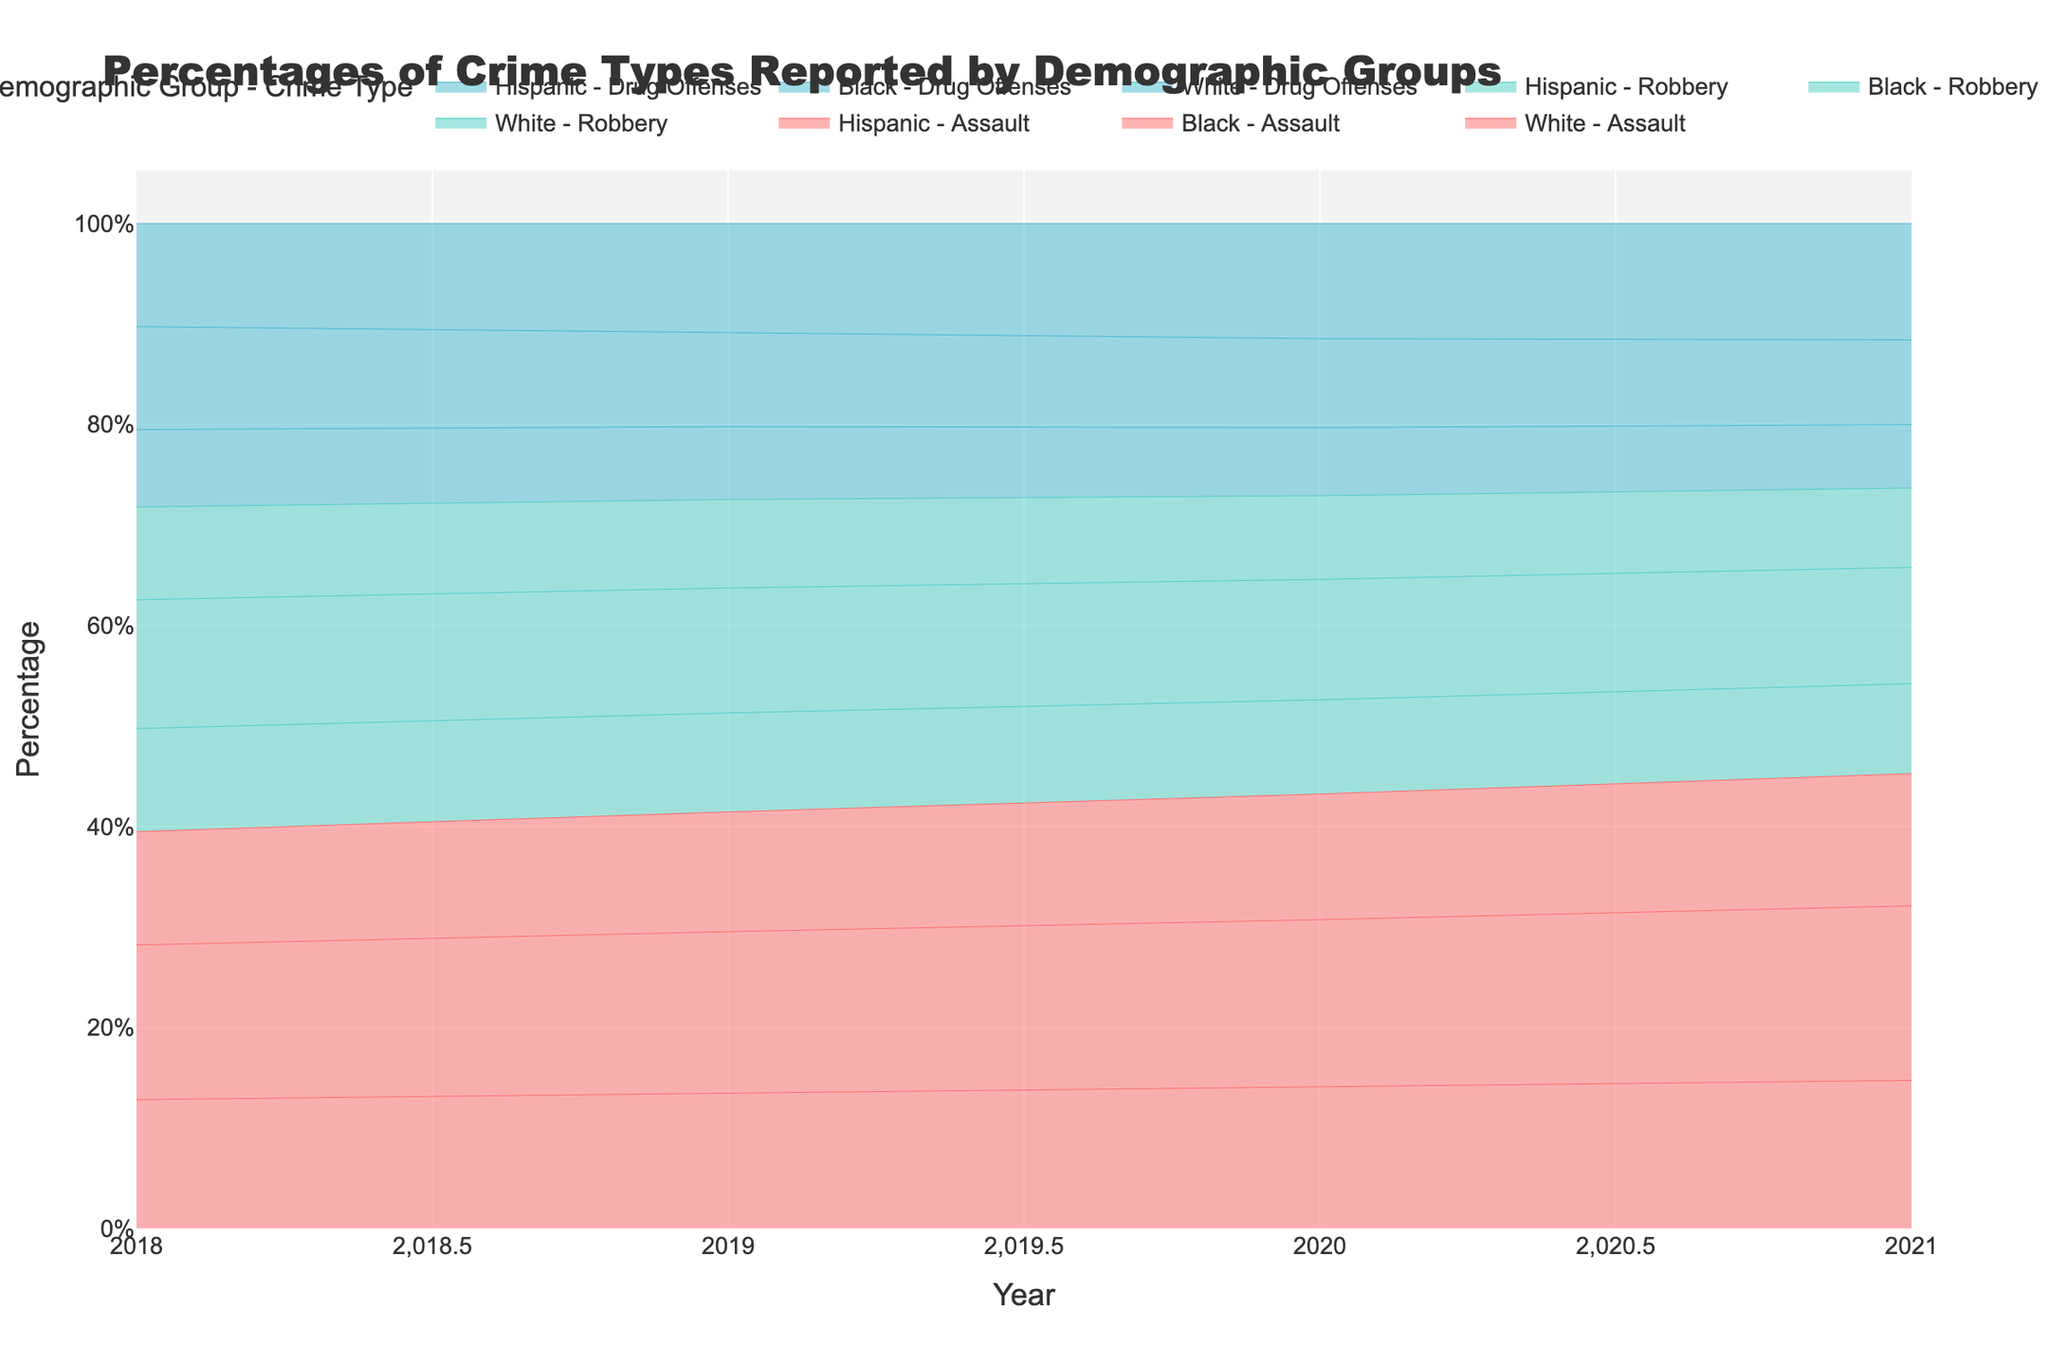What is the title of the chart? The title is typically displayed at the top of the chart and provides a brief explanation of what the chart is about. In this case, it should mention the percentages, crime types, demographic groups, and the timeframe.
Answer: Percentages of Crime Types Reported by Demographic Groups What is the y-axis title? The title of the y-axis is displayed vertically along the y-axis and indicates what is being measured on the y-axis.
Answer: Percentage What are the colors representing 'Assault', 'Robbery', and 'Drug Offenses'? The colors differentiating 'Assault', 'Robbery', and 'Drug Offenses' help in distinguishing between the different crime types. By examining the chart legend, we can determine which color corresponds to which crime type.
Answer: Red, Blue, Cyan How has the percentage of 'Assault' among the Black demographic changed from 2018 to 2021? By analyzing the areas represented by 'Assault' in the Black demographic across the different years from the base to the top, we can see the change in percentage.
Answer: Increased from 30% to 33% Which demographic group had the lowest reported percentage of 'Drug Offenses' in 2021? By comparing the areas representing 'Drug Offenses' for each demographic group in 2021, we identify which group had the smallest area.
Answer: White What was the percentage difference of 'Robbery' between the Hispanic and White demographics in 2020? First, find the percentage of 'Robbery' for both Hispanic and White demographics in 2020 and then calculate the difference by subtracting the smaller percentage from the larger one.
Answer: 2% Was there any year in which the percentage of 'Drug Offenses' for the Hispanic group remained the same? By scanning through the values for 'Drug Offenses' reported by the Hispanic group over the years, we can check for any constant values.
Answer: Yes, 22% in both 2020 and 2021 By how much did the reported percentage of 'Drug Offenses' among the White demographic decrease from 2018 to 2021? Calculate the percentage of 'Drug Offenses' for the White demographic in 2018 and 2021 and then find the difference.
Answer: 3% Which crime type reported the highest percentage increase for the White demographic from 2018 to 2021? Compare the percentages of each crime type for the White demographic between 2018 and 2021 and determine the highest increase by calculating the differences.
Answer: Assault 